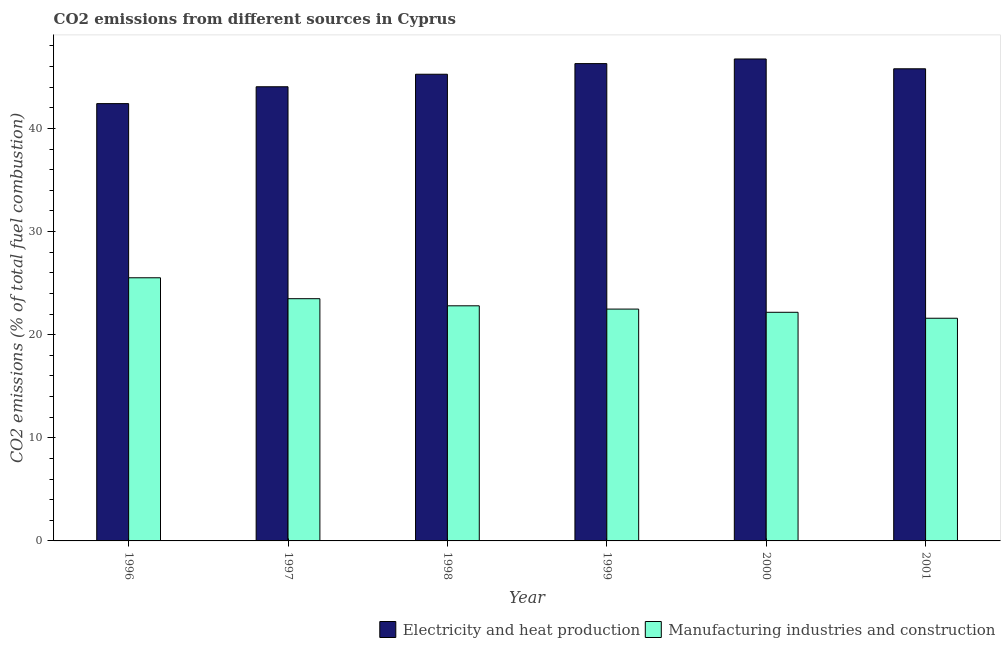Are the number of bars per tick equal to the number of legend labels?
Give a very brief answer. Yes. How many bars are there on the 5th tick from the left?
Offer a terse response. 2. How many bars are there on the 2nd tick from the right?
Offer a very short reply. 2. What is the label of the 2nd group of bars from the left?
Ensure brevity in your answer.  1997. In how many cases, is the number of bars for a given year not equal to the number of legend labels?
Provide a short and direct response. 0. What is the co2 emissions due to electricity and heat production in 1997?
Offer a terse response. 44.04. Across all years, what is the maximum co2 emissions due to manufacturing industries?
Provide a succinct answer. 25.52. Across all years, what is the minimum co2 emissions due to electricity and heat production?
Your answer should be very brief. 42.4. In which year was the co2 emissions due to manufacturing industries minimum?
Make the answer very short. 2001. What is the total co2 emissions due to manufacturing industries in the graph?
Give a very brief answer. 138.04. What is the difference between the co2 emissions due to manufacturing industries in 1996 and that in 2000?
Keep it short and to the point. 3.35. What is the difference between the co2 emissions due to manufacturing industries in 2000 and the co2 emissions due to electricity and heat production in 1999?
Your answer should be very brief. -0.31. What is the average co2 emissions due to manufacturing industries per year?
Your answer should be compact. 23.01. What is the ratio of the co2 emissions due to electricity and heat production in 1997 to that in 2000?
Ensure brevity in your answer.  0.94. Is the difference between the co2 emissions due to electricity and heat production in 1997 and 2001 greater than the difference between the co2 emissions due to manufacturing industries in 1997 and 2001?
Offer a terse response. No. What is the difference between the highest and the second highest co2 emissions due to electricity and heat production?
Ensure brevity in your answer.  0.45. What is the difference between the highest and the lowest co2 emissions due to electricity and heat production?
Offer a terse response. 4.33. Is the sum of the co2 emissions due to manufacturing industries in 1997 and 2000 greater than the maximum co2 emissions due to electricity and heat production across all years?
Ensure brevity in your answer.  Yes. What does the 2nd bar from the left in 1996 represents?
Give a very brief answer. Manufacturing industries and construction. What does the 1st bar from the right in 2001 represents?
Make the answer very short. Manufacturing industries and construction. How many bars are there?
Your response must be concise. 12. Are all the bars in the graph horizontal?
Your answer should be compact. No. Are the values on the major ticks of Y-axis written in scientific E-notation?
Give a very brief answer. No. Does the graph contain any zero values?
Provide a short and direct response. No. How many legend labels are there?
Offer a very short reply. 2. What is the title of the graph?
Make the answer very short. CO2 emissions from different sources in Cyprus. What is the label or title of the X-axis?
Offer a terse response. Year. What is the label or title of the Y-axis?
Your answer should be compact. CO2 emissions (% of total fuel combustion). What is the CO2 emissions (% of total fuel combustion) of Electricity and heat production in 1996?
Offer a terse response. 42.4. What is the CO2 emissions (% of total fuel combustion) in Manufacturing industries and construction in 1996?
Your answer should be compact. 25.52. What is the CO2 emissions (% of total fuel combustion) in Electricity and heat production in 1997?
Ensure brevity in your answer.  44.04. What is the CO2 emissions (% of total fuel combustion) of Manufacturing industries and construction in 1997?
Provide a succinct answer. 23.49. What is the CO2 emissions (% of total fuel combustion) of Electricity and heat production in 1998?
Offer a very short reply. 45.25. What is the CO2 emissions (% of total fuel combustion) in Manufacturing industries and construction in 1998?
Offer a terse response. 22.8. What is the CO2 emissions (% of total fuel combustion) in Electricity and heat production in 1999?
Ensure brevity in your answer.  46.28. What is the CO2 emissions (% of total fuel combustion) in Manufacturing industries and construction in 1999?
Provide a succinct answer. 22.48. What is the CO2 emissions (% of total fuel combustion) of Electricity and heat production in 2000?
Offer a terse response. 46.73. What is the CO2 emissions (% of total fuel combustion) in Manufacturing industries and construction in 2000?
Keep it short and to the point. 22.17. What is the CO2 emissions (% of total fuel combustion) in Electricity and heat production in 2001?
Offer a very short reply. 45.78. What is the CO2 emissions (% of total fuel combustion) in Manufacturing industries and construction in 2001?
Your answer should be very brief. 21.59. Across all years, what is the maximum CO2 emissions (% of total fuel combustion) of Electricity and heat production?
Provide a short and direct response. 46.73. Across all years, what is the maximum CO2 emissions (% of total fuel combustion) of Manufacturing industries and construction?
Ensure brevity in your answer.  25.52. Across all years, what is the minimum CO2 emissions (% of total fuel combustion) in Electricity and heat production?
Provide a succinct answer. 42.4. Across all years, what is the minimum CO2 emissions (% of total fuel combustion) in Manufacturing industries and construction?
Keep it short and to the point. 21.59. What is the total CO2 emissions (% of total fuel combustion) of Electricity and heat production in the graph?
Give a very brief answer. 270.48. What is the total CO2 emissions (% of total fuel combustion) in Manufacturing industries and construction in the graph?
Your response must be concise. 138.04. What is the difference between the CO2 emissions (% of total fuel combustion) in Electricity and heat production in 1996 and that in 1997?
Your answer should be very brief. -1.64. What is the difference between the CO2 emissions (% of total fuel combustion) in Manufacturing industries and construction in 1996 and that in 1997?
Keep it short and to the point. 2.03. What is the difference between the CO2 emissions (% of total fuel combustion) in Electricity and heat production in 1996 and that in 1998?
Provide a succinct answer. -2.85. What is the difference between the CO2 emissions (% of total fuel combustion) in Manufacturing industries and construction in 1996 and that in 1998?
Provide a succinct answer. 2.72. What is the difference between the CO2 emissions (% of total fuel combustion) in Electricity and heat production in 1996 and that in 1999?
Offer a terse response. -3.88. What is the difference between the CO2 emissions (% of total fuel combustion) of Manufacturing industries and construction in 1996 and that in 1999?
Provide a short and direct response. 3.04. What is the difference between the CO2 emissions (% of total fuel combustion) in Electricity and heat production in 1996 and that in 2000?
Provide a succinct answer. -4.33. What is the difference between the CO2 emissions (% of total fuel combustion) of Manufacturing industries and construction in 1996 and that in 2000?
Your response must be concise. 3.35. What is the difference between the CO2 emissions (% of total fuel combustion) in Electricity and heat production in 1996 and that in 2001?
Your response must be concise. -3.38. What is the difference between the CO2 emissions (% of total fuel combustion) in Manufacturing industries and construction in 1996 and that in 2001?
Ensure brevity in your answer.  3.92. What is the difference between the CO2 emissions (% of total fuel combustion) of Electricity and heat production in 1997 and that in 1998?
Your answer should be very brief. -1.21. What is the difference between the CO2 emissions (% of total fuel combustion) in Manufacturing industries and construction in 1997 and that in 1998?
Give a very brief answer. 0.69. What is the difference between the CO2 emissions (% of total fuel combustion) of Electricity and heat production in 1997 and that in 1999?
Provide a short and direct response. -2.24. What is the difference between the CO2 emissions (% of total fuel combustion) in Manufacturing industries and construction in 1997 and that in 1999?
Give a very brief answer. 1.01. What is the difference between the CO2 emissions (% of total fuel combustion) in Electricity and heat production in 1997 and that in 2000?
Offer a very short reply. -2.69. What is the difference between the CO2 emissions (% of total fuel combustion) in Manufacturing industries and construction in 1997 and that in 2000?
Keep it short and to the point. 1.32. What is the difference between the CO2 emissions (% of total fuel combustion) of Electricity and heat production in 1997 and that in 2001?
Offer a very short reply. -1.74. What is the difference between the CO2 emissions (% of total fuel combustion) in Manufacturing industries and construction in 1997 and that in 2001?
Provide a short and direct response. 1.9. What is the difference between the CO2 emissions (% of total fuel combustion) in Electricity and heat production in 1998 and that in 1999?
Make the answer very short. -1.03. What is the difference between the CO2 emissions (% of total fuel combustion) in Manufacturing industries and construction in 1998 and that in 1999?
Make the answer very short. 0.32. What is the difference between the CO2 emissions (% of total fuel combustion) in Electricity and heat production in 1998 and that in 2000?
Your answer should be very brief. -1.48. What is the difference between the CO2 emissions (% of total fuel combustion) in Manufacturing industries and construction in 1998 and that in 2000?
Offer a very short reply. 0.63. What is the difference between the CO2 emissions (% of total fuel combustion) in Electricity and heat production in 1998 and that in 2001?
Give a very brief answer. -0.53. What is the difference between the CO2 emissions (% of total fuel combustion) of Manufacturing industries and construction in 1998 and that in 2001?
Your response must be concise. 1.21. What is the difference between the CO2 emissions (% of total fuel combustion) in Electricity and heat production in 1999 and that in 2000?
Ensure brevity in your answer.  -0.45. What is the difference between the CO2 emissions (% of total fuel combustion) of Manufacturing industries and construction in 1999 and that in 2000?
Your answer should be very brief. 0.31. What is the difference between the CO2 emissions (% of total fuel combustion) of Electricity and heat production in 1999 and that in 2001?
Keep it short and to the point. 0.5. What is the difference between the CO2 emissions (% of total fuel combustion) of Manufacturing industries and construction in 1999 and that in 2001?
Keep it short and to the point. 0.89. What is the difference between the CO2 emissions (% of total fuel combustion) in Electricity and heat production in 2000 and that in 2001?
Offer a terse response. 0.95. What is the difference between the CO2 emissions (% of total fuel combustion) of Manufacturing industries and construction in 2000 and that in 2001?
Your answer should be very brief. 0.58. What is the difference between the CO2 emissions (% of total fuel combustion) in Electricity and heat production in 1996 and the CO2 emissions (% of total fuel combustion) in Manufacturing industries and construction in 1997?
Provide a succinct answer. 18.92. What is the difference between the CO2 emissions (% of total fuel combustion) in Electricity and heat production in 1996 and the CO2 emissions (% of total fuel combustion) in Manufacturing industries and construction in 1998?
Ensure brevity in your answer.  19.6. What is the difference between the CO2 emissions (% of total fuel combustion) of Electricity and heat production in 1996 and the CO2 emissions (% of total fuel combustion) of Manufacturing industries and construction in 1999?
Your response must be concise. 19.92. What is the difference between the CO2 emissions (% of total fuel combustion) of Electricity and heat production in 1996 and the CO2 emissions (% of total fuel combustion) of Manufacturing industries and construction in 2000?
Offer a terse response. 20.23. What is the difference between the CO2 emissions (% of total fuel combustion) of Electricity and heat production in 1996 and the CO2 emissions (% of total fuel combustion) of Manufacturing industries and construction in 2001?
Keep it short and to the point. 20.81. What is the difference between the CO2 emissions (% of total fuel combustion) of Electricity and heat production in 1997 and the CO2 emissions (% of total fuel combustion) of Manufacturing industries and construction in 1998?
Give a very brief answer. 21.24. What is the difference between the CO2 emissions (% of total fuel combustion) in Electricity and heat production in 1997 and the CO2 emissions (% of total fuel combustion) in Manufacturing industries and construction in 1999?
Offer a very short reply. 21.56. What is the difference between the CO2 emissions (% of total fuel combustion) in Electricity and heat production in 1997 and the CO2 emissions (% of total fuel combustion) in Manufacturing industries and construction in 2000?
Ensure brevity in your answer.  21.87. What is the difference between the CO2 emissions (% of total fuel combustion) of Electricity and heat production in 1997 and the CO2 emissions (% of total fuel combustion) of Manufacturing industries and construction in 2001?
Your answer should be compact. 22.45. What is the difference between the CO2 emissions (% of total fuel combustion) of Electricity and heat production in 1998 and the CO2 emissions (% of total fuel combustion) of Manufacturing industries and construction in 1999?
Provide a short and direct response. 22.77. What is the difference between the CO2 emissions (% of total fuel combustion) of Electricity and heat production in 1998 and the CO2 emissions (% of total fuel combustion) of Manufacturing industries and construction in 2000?
Give a very brief answer. 23.08. What is the difference between the CO2 emissions (% of total fuel combustion) in Electricity and heat production in 1998 and the CO2 emissions (% of total fuel combustion) in Manufacturing industries and construction in 2001?
Offer a terse response. 23.66. What is the difference between the CO2 emissions (% of total fuel combustion) in Electricity and heat production in 1999 and the CO2 emissions (% of total fuel combustion) in Manufacturing industries and construction in 2000?
Your answer should be very brief. 24.11. What is the difference between the CO2 emissions (% of total fuel combustion) of Electricity and heat production in 1999 and the CO2 emissions (% of total fuel combustion) of Manufacturing industries and construction in 2001?
Keep it short and to the point. 24.69. What is the difference between the CO2 emissions (% of total fuel combustion) of Electricity and heat production in 2000 and the CO2 emissions (% of total fuel combustion) of Manufacturing industries and construction in 2001?
Give a very brief answer. 25.14. What is the average CO2 emissions (% of total fuel combustion) of Electricity and heat production per year?
Your response must be concise. 45.08. What is the average CO2 emissions (% of total fuel combustion) in Manufacturing industries and construction per year?
Offer a terse response. 23.01. In the year 1996, what is the difference between the CO2 emissions (% of total fuel combustion) in Electricity and heat production and CO2 emissions (% of total fuel combustion) in Manufacturing industries and construction?
Offer a terse response. 16.89. In the year 1997, what is the difference between the CO2 emissions (% of total fuel combustion) in Electricity and heat production and CO2 emissions (% of total fuel combustion) in Manufacturing industries and construction?
Give a very brief answer. 20.55. In the year 1998, what is the difference between the CO2 emissions (% of total fuel combustion) in Electricity and heat production and CO2 emissions (% of total fuel combustion) in Manufacturing industries and construction?
Your answer should be compact. 22.45. In the year 1999, what is the difference between the CO2 emissions (% of total fuel combustion) in Electricity and heat production and CO2 emissions (% of total fuel combustion) in Manufacturing industries and construction?
Ensure brevity in your answer.  23.8. In the year 2000, what is the difference between the CO2 emissions (% of total fuel combustion) in Electricity and heat production and CO2 emissions (% of total fuel combustion) in Manufacturing industries and construction?
Ensure brevity in your answer.  24.56. In the year 2001, what is the difference between the CO2 emissions (% of total fuel combustion) in Electricity and heat production and CO2 emissions (% of total fuel combustion) in Manufacturing industries and construction?
Your answer should be compact. 24.19. What is the ratio of the CO2 emissions (% of total fuel combustion) of Electricity and heat production in 1996 to that in 1997?
Your answer should be very brief. 0.96. What is the ratio of the CO2 emissions (% of total fuel combustion) in Manufacturing industries and construction in 1996 to that in 1997?
Offer a very short reply. 1.09. What is the ratio of the CO2 emissions (% of total fuel combustion) in Electricity and heat production in 1996 to that in 1998?
Your answer should be compact. 0.94. What is the ratio of the CO2 emissions (% of total fuel combustion) in Manufacturing industries and construction in 1996 to that in 1998?
Ensure brevity in your answer.  1.12. What is the ratio of the CO2 emissions (% of total fuel combustion) in Electricity and heat production in 1996 to that in 1999?
Your answer should be compact. 0.92. What is the ratio of the CO2 emissions (% of total fuel combustion) of Manufacturing industries and construction in 1996 to that in 1999?
Your response must be concise. 1.14. What is the ratio of the CO2 emissions (% of total fuel combustion) in Electricity and heat production in 1996 to that in 2000?
Keep it short and to the point. 0.91. What is the ratio of the CO2 emissions (% of total fuel combustion) of Manufacturing industries and construction in 1996 to that in 2000?
Ensure brevity in your answer.  1.15. What is the ratio of the CO2 emissions (% of total fuel combustion) in Electricity and heat production in 1996 to that in 2001?
Provide a short and direct response. 0.93. What is the ratio of the CO2 emissions (% of total fuel combustion) in Manufacturing industries and construction in 1996 to that in 2001?
Make the answer very short. 1.18. What is the ratio of the CO2 emissions (% of total fuel combustion) of Electricity and heat production in 1997 to that in 1998?
Give a very brief answer. 0.97. What is the ratio of the CO2 emissions (% of total fuel combustion) of Manufacturing industries and construction in 1997 to that in 1998?
Your answer should be very brief. 1.03. What is the ratio of the CO2 emissions (% of total fuel combustion) of Electricity and heat production in 1997 to that in 1999?
Provide a succinct answer. 0.95. What is the ratio of the CO2 emissions (% of total fuel combustion) of Manufacturing industries and construction in 1997 to that in 1999?
Ensure brevity in your answer.  1.04. What is the ratio of the CO2 emissions (% of total fuel combustion) of Electricity and heat production in 1997 to that in 2000?
Provide a succinct answer. 0.94. What is the ratio of the CO2 emissions (% of total fuel combustion) in Manufacturing industries and construction in 1997 to that in 2000?
Give a very brief answer. 1.06. What is the ratio of the CO2 emissions (% of total fuel combustion) of Electricity and heat production in 1997 to that in 2001?
Ensure brevity in your answer.  0.96. What is the ratio of the CO2 emissions (% of total fuel combustion) of Manufacturing industries and construction in 1997 to that in 2001?
Offer a terse response. 1.09. What is the ratio of the CO2 emissions (% of total fuel combustion) in Electricity and heat production in 1998 to that in 1999?
Give a very brief answer. 0.98. What is the ratio of the CO2 emissions (% of total fuel combustion) in Manufacturing industries and construction in 1998 to that in 1999?
Your answer should be compact. 1.01. What is the ratio of the CO2 emissions (% of total fuel combustion) of Electricity and heat production in 1998 to that in 2000?
Offer a terse response. 0.97. What is the ratio of the CO2 emissions (% of total fuel combustion) of Manufacturing industries and construction in 1998 to that in 2000?
Your response must be concise. 1.03. What is the ratio of the CO2 emissions (% of total fuel combustion) in Electricity and heat production in 1998 to that in 2001?
Your answer should be very brief. 0.99. What is the ratio of the CO2 emissions (% of total fuel combustion) of Manufacturing industries and construction in 1998 to that in 2001?
Ensure brevity in your answer.  1.06. What is the ratio of the CO2 emissions (% of total fuel combustion) in Electricity and heat production in 1999 to that in 2000?
Your response must be concise. 0.99. What is the ratio of the CO2 emissions (% of total fuel combustion) of Manufacturing industries and construction in 1999 to that in 2000?
Your answer should be compact. 1.01. What is the ratio of the CO2 emissions (% of total fuel combustion) of Electricity and heat production in 1999 to that in 2001?
Give a very brief answer. 1.01. What is the ratio of the CO2 emissions (% of total fuel combustion) of Manufacturing industries and construction in 1999 to that in 2001?
Your answer should be very brief. 1.04. What is the ratio of the CO2 emissions (% of total fuel combustion) in Electricity and heat production in 2000 to that in 2001?
Keep it short and to the point. 1.02. What is the ratio of the CO2 emissions (% of total fuel combustion) of Manufacturing industries and construction in 2000 to that in 2001?
Keep it short and to the point. 1.03. What is the difference between the highest and the second highest CO2 emissions (% of total fuel combustion) in Electricity and heat production?
Offer a very short reply. 0.45. What is the difference between the highest and the second highest CO2 emissions (% of total fuel combustion) of Manufacturing industries and construction?
Ensure brevity in your answer.  2.03. What is the difference between the highest and the lowest CO2 emissions (% of total fuel combustion) of Electricity and heat production?
Provide a short and direct response. 4.33. What is the difference between the highest and the lowest CO2 emissions (% of total fuel combustion) in Manufacturing industries and construction?
Your response must be concise. 3.92. 